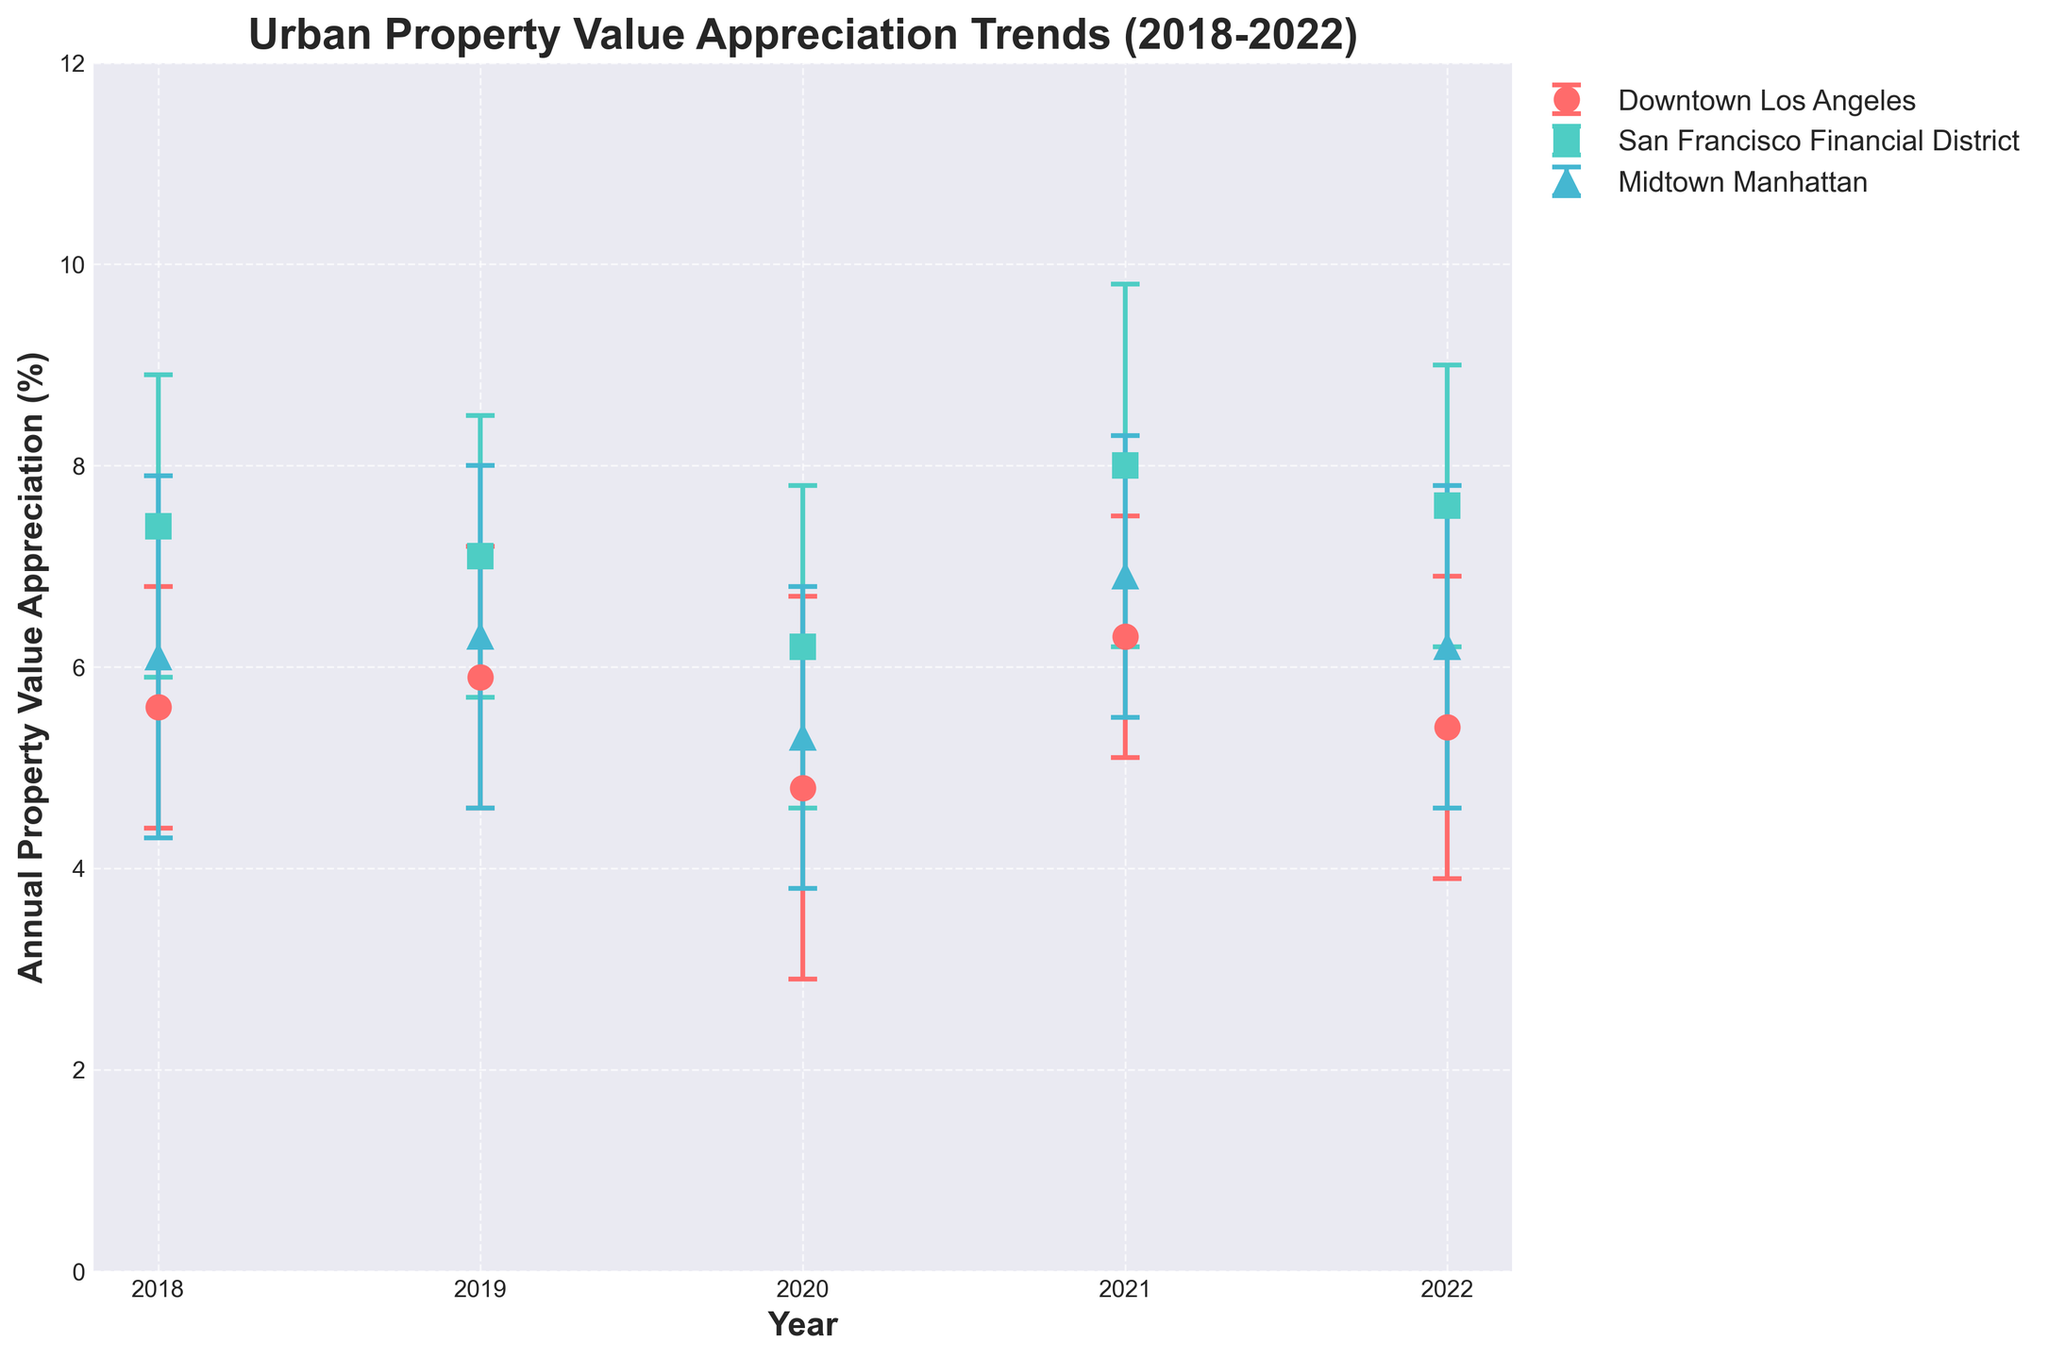What is the title of the figure? The title is written at the top of the figure, indicating what the figure is about. The title reads "Urban Property Value Appreciation Trends (2018-2022)".
Answer: Urban Property Value Appreciation Trends (2018-2022) Which urban zone had the highest property value appreciation in 2021? Look at the error bars labeled 2021 and check the appreciation percentages for each urban zone. San Francisco Financial District has the highest value at 8.0%.
Answer: San Francisco Financial District How has property value appreciation changed for Downtown Los Angeles from 2018 to 2022? Downtown Los Angeles had an appreciation rate of 5.6% in 2018 and 5.4% in 2022. The rate increased to 5.9% in 2019 and peaked at 6.3% in 2021 before decreasing again.
Answer: It slightly decreased from 5.6% to 5.4% Which year had the lowest overall property value appreciation in San Francisco Financial District? Identify the points for San Francisco Financial District across the years and note their corresponding appreciation rates. The lowest rate is in 2020 with 6.2%.
Answer: 2020 What is the standard deviation for Midtown Manhattan’s property value appreciation in 2019, and what does it indicate? Review the error bars for Midtown Manhattan in 2019. The standard deviation is 1.7%, indicating variability in property value appreciation.
Answer: 1.7% Between which years was the most significant reduction in property value appreciation for Midtown Manhattan observed? Compare appreciation rates year by year for Midtown Manhattan and note the differences. The largest drop is from 2021 to 2022, from 6.9% to 6.2%.
Answer: 2021 to 2022 Which urban zone has the most consistent property value appreciation over the years, based on standard deviation? Evaluate the standard deviations for all urban zones across all years. Downtown Los Angeles typically has lower standard deviations compared to the other zones.
Answer: Downtown Los Angeles What was the general trend for property value appreciation in all zones between 2019 and 2020? Check the data points from 2019 and 2020 for all urban zones. All zones show a decrease in property value appreciation during this period.
Answer: Decreasing trend How do the annual property value appreciation rates for Downtown Los Angeles in 2020 and 2021 compare with their respective standard deviations? Compare both appreciation rates and their standard deviations: 4.8% with 1.9% (2020) and 6.3% with 1.2% (2021). The change is more significant relative to their standard deviations.
Answer: 4.8% (1.9%) and 6.3% (1.2%) Based on the figure, can you predict which urban zone might have the highest appreciation in 2023? Examine the trends up to 2022. San Francisco Financial District shows consistently high appreciation rates, suggesting it might continue to lead in 2023.
Answer: San Francisco Financial District 